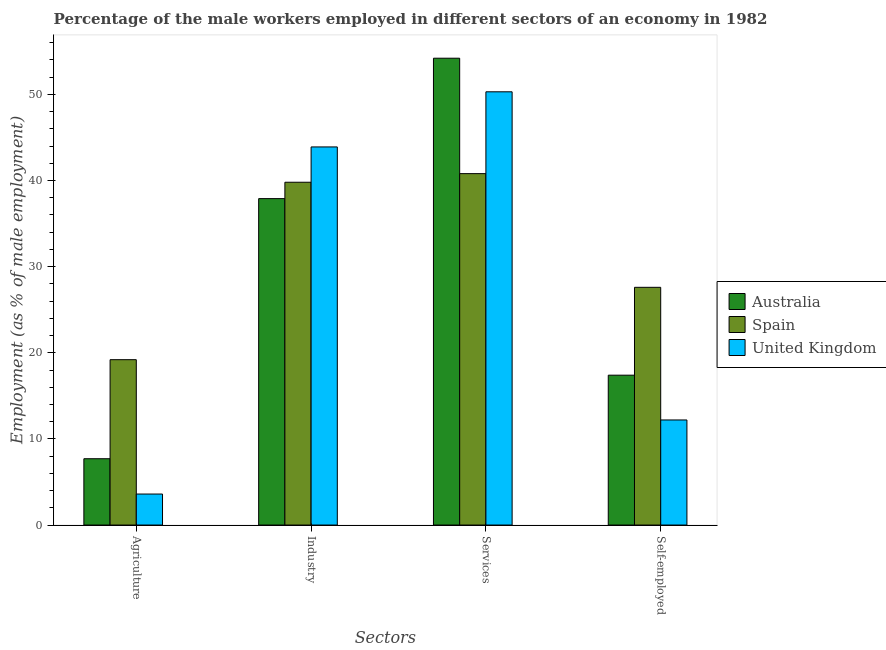How many different coloured bars are there?
Offer a very short reply. 3. How many bars are there on the 3rd tick from the right?
Offer a terse response. 3. What is the label of the 3rd group of bars from the left?
Make the answer very short. Services. What is the percentage of self employed male workers in Australia?
Your response must be concise. 17.4. Across all countries, what is the maximum percentage of male workers in industry?
Offer a terse response. 43.9. Across all countries, what is the minimum percentage of male workers in services?
Your answer should be compact. 40.8. In which country was the percentage of self employed male workers maximum?
Keep it short and to the point. Spain. What is the total percentage of male workers in industry in the graph?
Offer a terse response. 121.6. What is the difference between the percentage of male workers in agriculture in Australia and that in United Kingdom?
Offer a very short reply. 4.1. What is the difference between the percentage of male workers in industry in Spain and the percentage of male workers in agriculture in United Kingdom?
Your answer should be very brief. 36.2. What is the average percentage of male workers in services per country?
Provide a short and direct response. 48.43. In how many countries, is the percentage of male workers in agriculture greater than 18 %?
Ensure brevity in your answer.  1. What is the ratio of the percentage of male workers in services in Australia to that in United Kingdom?
Your answer should be very brief. 1.08. Is the percentage of male workers in services in Australia less than that in United Kingdom?
Your response must be concise. No. What is the difference between the highest and the second highest percentage of male workers in industry?
Make the answer very short. 4.1. What is the difference between the highest and the lowest percentage of male workers in services?
Provide a succinct answer. 13.4. In how many countries, is the percentage of self employed male workers greater than the average percentage of self employed male workers taken over all countries?
Ensure brevity in your answer.  1. Is the sum of the percentage of male workers in services in Spain and Australia greater than the maximum percentage of male workers in agriculture across all countries?
Ensure brevity in your answer.  Yes. Is it the case that in every country, the sum of the percentage of male workers in agriculture and percentage of male workers in services is greater than the sum of percentage of male workers in industry and percentage of self employed male workers?
Provide a succinct answer. Yes. What does the 3rd bar from the left in Industry represents?
Offer a terse response. United Kingdom. Are all the bars in the graph horizontal?
Offer a very short reply. No. How many countries are there in the graph?
Offer a very short reply. 3. What is the difference between two consecutive major ticks on the Y-axis?
Offer a terse response. 10. Are the values on the major ticks of Y-axis written in scientific E-notation?
Your response must be concise. No. Where does the legend appear in the graph?
Your answer should be very brief. Center right. How many legend labels are there?
Provide a succinct answer. 3. What is the title of the graph?
Make the answer very short. Percentage of the male workers employed in different sectors of an economy in 1982. What is the label or title of the X-axis?
Offer a very short reply. Sectors. What is the label or title of the Y-axis?
Give a very brief answer. Employment (as % of male employment). What is the Employment (as % of male employment) in Australia in Agriculture?
Your answer should be very brief. 7.7. What is the Employment (as % of male employment) in Spain in Agriculture?
Your response must be concise. 19.2. What is the Employment (as % of male employment) of United Kingdom in Agriculture?
Offer a very short reply. 3.6. What is the Employment (as % of male employment) of Australia in Industry?
Your answer should be compact. 37.9. What is the Employment (as % of male employment) of Spain in Industry?
Your response must be concise. 39.8. What is the Employment (as % of male employment) of United Kingdom in Industry?
Your answer should be very brief. 43.9. What is the Employment (as % of male employment) of Australia in Services?
Offer a terse response. 54.2. What is the Employment (as % of male employment) in Spain in Services?
Keep it short and to the point. 40.8. What is the Employment (as % of male employment) in United Kingdom in Services?
Make the answer very short. 50.3. What is the Employment (as % of male employment) in Australia in Self-employed?
Make the answer very short. 17.4. What is the Employment (as % of male employment) in Spain in Self-employed?
Ensure brevity in your answer.  27.6. What is the Employment (as % of male employment) in United Kingdom in Self-employed?
Offer a terse response. 12.2. Across all Sectors, what is the maximum Employment (as % of male employment) of Australia?
Your response must be concise. 54.2. Across all Sectors, what is the maximum Employment (as % of male employment) in Spain?
Your answer should be very brief. 40.8. Across all Sectors, what is the maximum Employment (as % of male employment) of United Kingdom?
Provide a short and direct response. 50.3. Across all Sectors, what is the minimum Employment (as % of male employment) of Australia?
Offer a terse response. 7.7. Across all Sectors, what is the minimum Employment (as % of male employment) of Spain?
Give a very brief answer. 19.2. Across all Sectors, what is the minimum Employment (as % of male employment) of United Kingdom?
Your answer should be compact. 3.6. What is the total Employment (as % of male employment) of Australia in the graph?
Offer a terse response. 117.2. What is the total Employment (as % of male employment) in Spain in the graph?
Your answer should be very brief. 127.4. What is the total Employment (as % of male employment) in United Kingdom in the graph?
Offer a terse response. 110. What is the difference between the Employment (as % of male employment) of Australia in Agriculture and that in Industry?
Provide a short and direct response. -30.2. What is the difference between the Employment (as % of male employment) of Spain in Agriculture and that in Industry?
Offer a very short reply. -20.6. What is the difference between the Employment (as % of male employment) in United Kingdom in Agriculture and that in Industry?
Offer a terse response. -40.3. What is the difference between the Employment (as % of male employment) of Australia in Agriculture and that in Services?
Your answer should be very brief. -46.5. What is the difference between the Employment (as % of male employment) of Spain in Agriculture and that in Services?
Make the answer very short. -21.6. What is the difference between the Employment (as % of male employment) of United Kingdom in Agriculture and that in Services?
Provide a short and direct response. -46.7. What is the difference between the Employment (as % of male employment) of United Kingdom in Agriculture and that in Self-employed?
Keep it short and to the point. -8.6. What is the difference between the Employment (as % of male employment) in Australia in Industry and that in Services?
Make the answer very short. -16.3. What is the difference between the Employment (as % of male employment) in Spain in Industry and that in Services?
Provide a succinct answer. -1. What is the difference between the Employment (as % of male employment) of United Kingdom in Industry and that in Services?
Keep it short and to the point. -6.4. What is the difference between the Employment (as % of male employment) of Australia in Industry and that in Self-employed?
Offer a very short reply. 20.5. What is the difference between the Employment (as % of male employment) of United Kingdom in Industry and that in Self-employed?
Provide a short and direct response. 31.7. What is the difference between the Employment (as % of male employment) in Australia in Services and that in Self-employed?
Your answer should be very brief. 36.8. What is the difference between the Employment (as % of male employment) in Spain in Services and that in Self-employed?
Offer a very short reply. 13.2. What is the difference between the Employment (as % of male employment) of United Kingdom in Services and that in Self-employed?
Give a very brief answer. 38.1. What is the difference between the Employment (as % of male employment) of Australia in Agriculture and the Employment (as % of male employment) of Spain in Industry?
Provide a succinct answer. -32.1. What is the difference between the Employment (as % of male employment) in Australia in Agriculture and the Employment (as % of male employment) in United Kingdom in Industry?
Provide a short and direct response. -36.2. What is the difference between the Employment (as % of male employment) of Spain in Agriculture and the Employment (as % of male employment) of United Kingdom in Industry?
Give a very brief answer. -24.7. What is the difference between the Employment (as % of male employment) in Australia in Agriculture and the Employment (as % of male employment) in Spain in Services?
Your answer should be compact. -33.1. What is the difference between the Employment (as % of male employment) of Australia in Agriculture and the Employment (as % of male employment) of United Kingdom in Services?
Offer a terse response. -42.6. What is the difference between the Employment (as % of male employment) in Spain in Agriculture and the Employment (as % of male employment) in United Kingdom in Services?
Make the answer very short. -31.1. What is the difference between the Employment (as % of male employment) of Australia in Agriculture and the Employment (as % of male employment) of Spain in Self-employed?
Offer a terse response. -19.9. What is the difference between the Employment (as % of male employment) in Spain in Agriculture and the Employment (as % of male employment) in United Kingdom in Self-employed?
Your response must be concise. 7. What is the difference between the Employment (as % of male employment) in Australia in Industry and the Employment (as % of male employment) in Spain in Services?
Your answer should be compact. -2.9. What is the difference between the Employment (as % of male employment) of Australia in Industry and the Employment (as % of male employment) of Spain in Self-employed?
Keep it short and to the point. 10.3. What is the difference between the Employment (as % of male employment) of Australia in Industry and the Employment (as % of male employment) of United Kingdom in Self-employed?
Provide a succinct answer. 25.7. What is the difference between the Employment (as % of male employment) in Spain in Industry and the Employment (as % of male employment) in United Kingdom in Self-employed?
Ensure brevity in your answer.  27.6. What is the difference between the Employment (as % of male employment) in Australia in Services and the Employment (as % of male employment) in Spain in Self-employed?
Your answer should be very brief. 26.6. What is the difference between the Employment (as % of male employment) in Australia in Services and the Employment (as % of male employment) in United Kingdom in Self-employed?
Offer a very short reply. 42. What is the difference between the Employment (as % of male employment) in Spain in Services and the Employment (as % of male employment) in United Kingdom in Self-employed?
Your answer should be very brief. 28.6. What is the average Employment (as % of male employment) of Australia per Sectors?
Ensure brevity in your answer.  29.3. What is the average Employment (as % of male employment) of Spain per Sectors?
Provide a short and direct response. 31.85. What is the average Employment (as % of male employment) in United Kingdom per Sectors?
Offer a very short reply. 27.5. What is the difference between the Employment (as % of male employment) in Australia and Employment (as % of male employment) in Spain in Agriculture?
Offer a very short reply. -11.5. What is the difference between the Employment (as % of male employment) of Australia and Employment (as % of male employment) of Spain in Industry?
Ensure brevity in your answer.  -1.9. What is the difference between the Employment (as % of male employment) in Australia and Employment (as % of male employment) in Spain in Services?
Provide a succinct answer. 13.4. What is the ratio of the Employment (as % of male employment) of Australia in Agriculture to that in Industry?
Your answer should be compact. 0.2. What is the ratio of the Employment (as % of male employment) of Spain in Agriculture to that in Industry?
Offer a very short reply. 0.48. What is the ratio of the Employment (as % of male employment) of United Kingdom in Agriculture to that in Industry?
Your answer should be compact. 0.08. What is the ratio of the Employment (as % of male employment) of Australia in Agriculture to that in Services?
Make the answer very short. 0.14. What is the ratio of the Employment (as % of male employment) of Spain in Agriculture to that in Services?
Give a very brief answer. 0.47. What is the ratio of the Employment (as % of male employment) in United Kingdom in Agriculture to that in Services?
Your answer should be very brief. 0.07. What is the ratio of the Employment (as % of male employment) in Australia in Agriculture to that in Self-employed?
Make the answer very short. 0.44. What is the ratio of the Employment (as % of male employment) in Spain in Agriculture to that in Self-employed?
Ensure brevity in your answer.  0.7. What is the ratio of the Employment (as % of male employment) of United Kingdom in Agriculture to that in Self-employed?
Offer a very short reply. 0.3. What is the ratio of the Employment (as % of male employment) in Australia in Industry to that in Services?
Make the answer very short. 0.7. What is the ratio of the Employment (as % of male employment) in Spain in Industry to that in Services?
Provide a short and direct response. 0.98. What is the ratio of the Employment (as % of male employment) in United Kingdom in Industry to that in Services?
Keep it short and to the point. 0.87. What is the ratio of the Employment (as % of male employment) of Australia in Industry to that in Self-employed?
Make the answer very short. 2.18. What is the ratio of the Employment (as % of male employment) of Spain in Industry to that in Self-employed?
Ensure brevity in your answer.  1.44. What is the ratio of the Employment (as % of male employment) of United Kingdom in Industry to that in Self-employed?
Provide a succinct answer. 3.6. What is the ratio of the Employment (as % of male employment) in Australia in Services to that in Self-employed?
Keep it short and to the point. 3.11. What is the ratio of the Employment (as % of male employment) of Spain in Services to that in Self-employed?
Your answer should be compact. 1.48. What is the ratio of the Employment (as % of male employment) of United Kingdom in Services to that in Self-employed?
Your answer should be very brief. 4.12. What is the difference between the highest and the second highest Employment (as % of male employment) of Australia?
Your response must be concise. 16.3. What is the difference between the highest and the second highest Employment (as % of male employment) of Spain?
Offer a very short reply. 1. What is the difference between the highest and the lowest Employment (as % of male employment) in Australia?
Keep it short and to the point. 46.5. What is the difference between the highest and the lowest Employment (as % of male employment) in Spain?
Make the answer very short. 21.6. What is the difference between the highest and the lowest Employment (as % of male employment) of United Kingdom?
Offer a terse response. 46.7. 